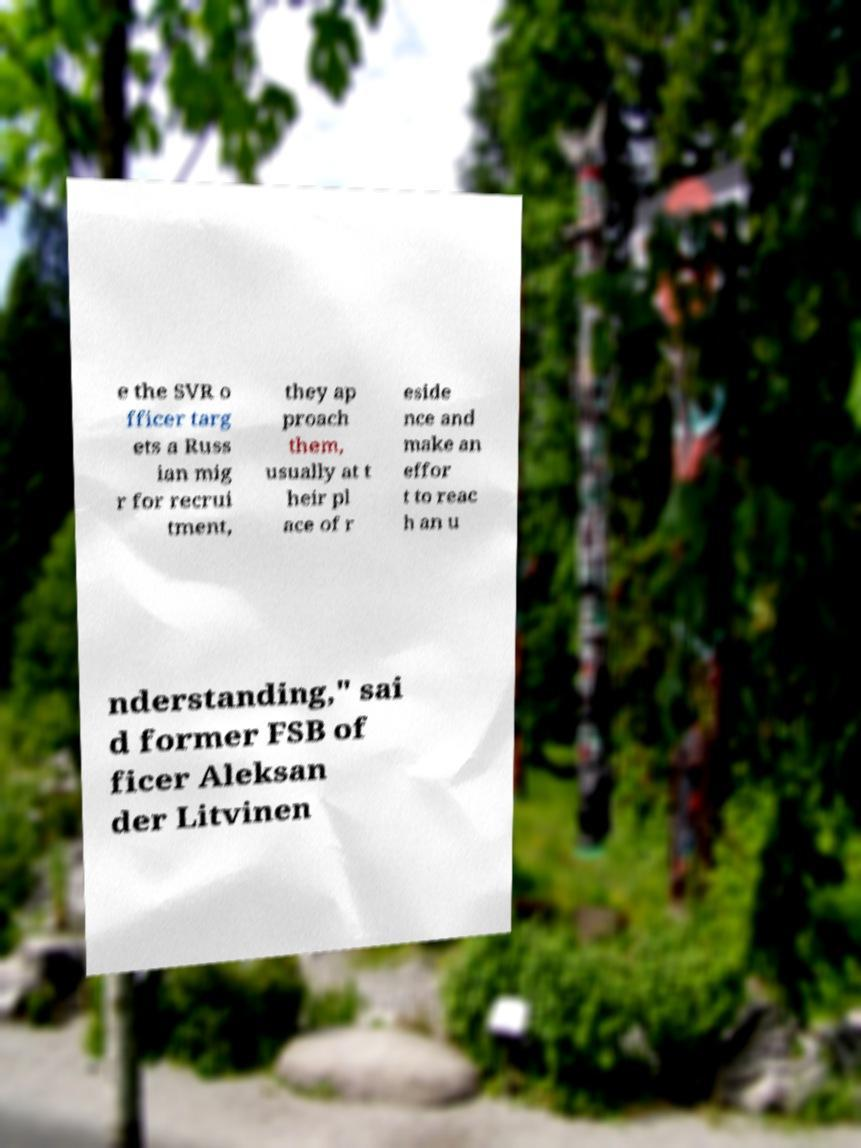What messages or text are displayed in this image? I need them in a readable, typed format. e the SVR o fficer targ ets a Russ ian mig r for recrui tment, they ap proach them, usually at t heir pl ace of r eside nce and make an effor t to reac h an u nderstanding," sai d former FSB of ficer Aleksan der Litvinen 